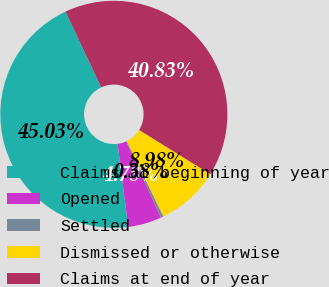Convert chart to OTSL. <chart><loc_0><loc_0><loc_500><loc_500><pie_chart><fcel>Claims at beginning of year<fcel>Opened<fcel>Settled<fcel>Dismissed or otherwise<fcel>Claims at end of year<nl><fcel>45.03%<fcel>4.78%<fcel>0.38%<fcel>8.98%<fcel>40.83%<nl></chart> 